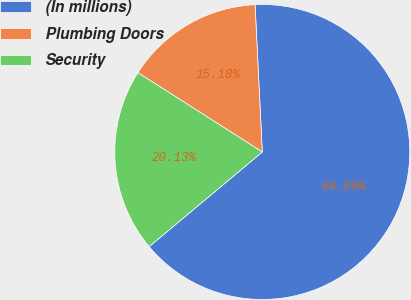Convert chart. <chart><loc_0><loc_0><loc_500><loc_500><pie_chart><fcel>(In millions)<fcel>Plumbing Doors<fcel>Security<nl><fcel>64.69%<fcel>15.18%<fcel>20.13%<nl></chart> 